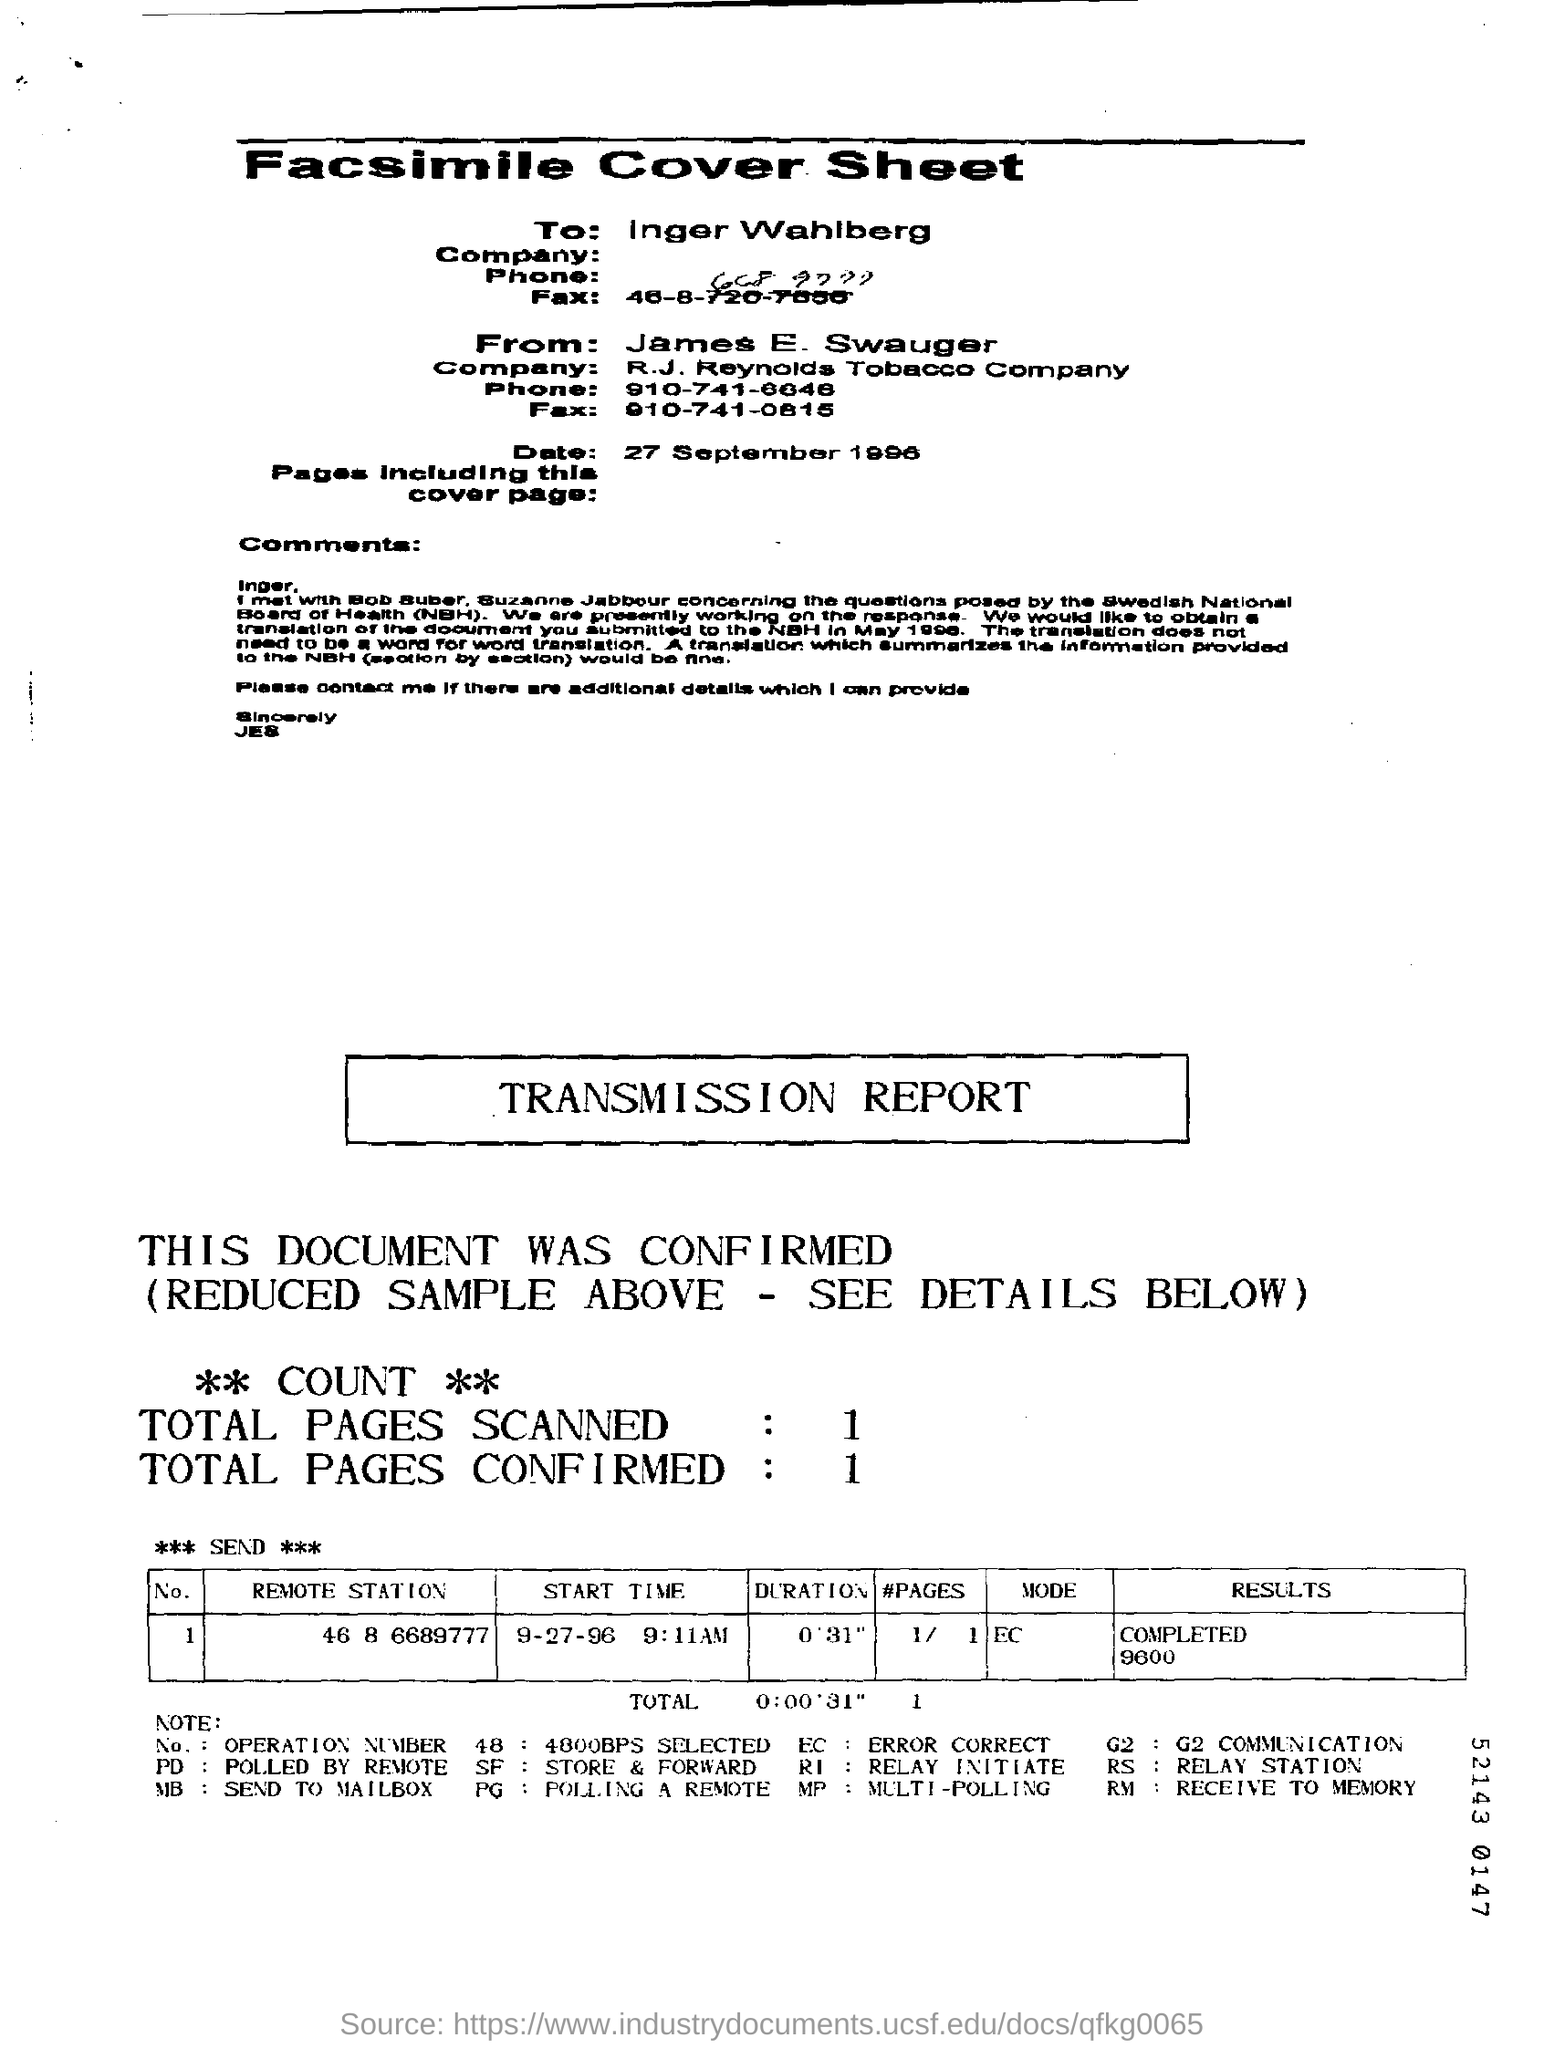Specify some key components in this picture. The transmission report confirms a total of one page. The date mentioned in the cover sheet is September 27, 1996. The transmission report shows the total number of pages scanned as 1.. The duration mentioned in the transmission report is 0' 31". 